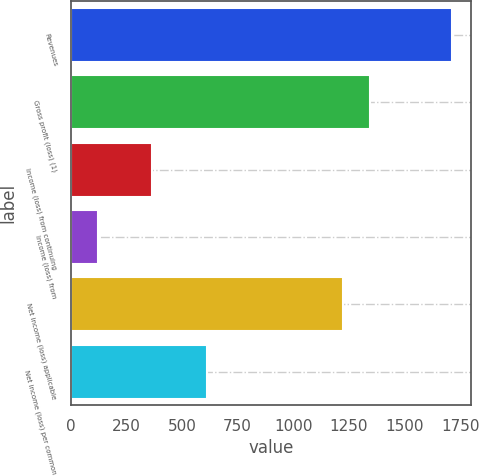Convert chart to OTSL. <chart><loc_0><loc_0><loc_500><loc_500><bar_chart><fcel>Revenues<fcel>Gross profit (loss) (1)<fcel>Income (loss) from continuing<fcel>Income (loss) from<fcel>Net income (loss) applicable<fcel>Net income (loss) per common<nl><fcel>1713.52<fcel>1346.35<fcel>367.23<fcel>122.45<fcel>1223.96<fcel>612.01<nl></chart> 